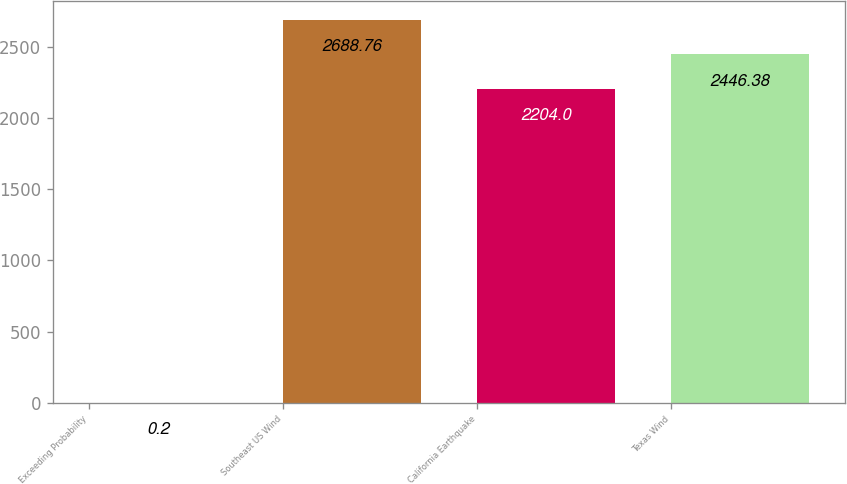Convert chart to OTSL. <chart><loc_0><loc_0><loc_500><loc_500><bar_chart><fcel>Exceeding Probability<fcel>Southeast US Wind<fcel>California Earthquake<fcel>Texas Wind<nl><fcel>0.2<fcel>2688.76<fcel>2204<fcel>2446.38<nl></chart> 